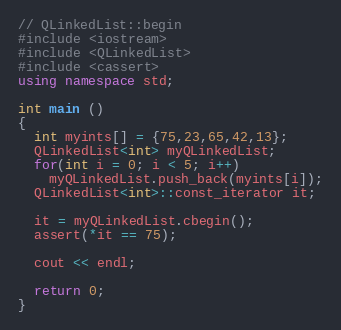Convert code to text. <code><loc_0><loc_0><loc_500><loc_500><_C++_>// QLinkedList::begin
#include <iostream>
#include <QLinkedList>
#include <cassert>
using namespace std;

int main ()
{
  int myints[] = {75,23,65,42,13};
  QLinkedList<int> myQLinkedList;
  for(int i = 0; i < 5; i++)
    myQLinkedList.push_back(myints[i]);
  QLinkedList<int>::const_iterator it;

  it = myQLinkedList.cbegin();
  assert(*it == 75);
  
  cout << endl;

  return 0;
}
</code> 